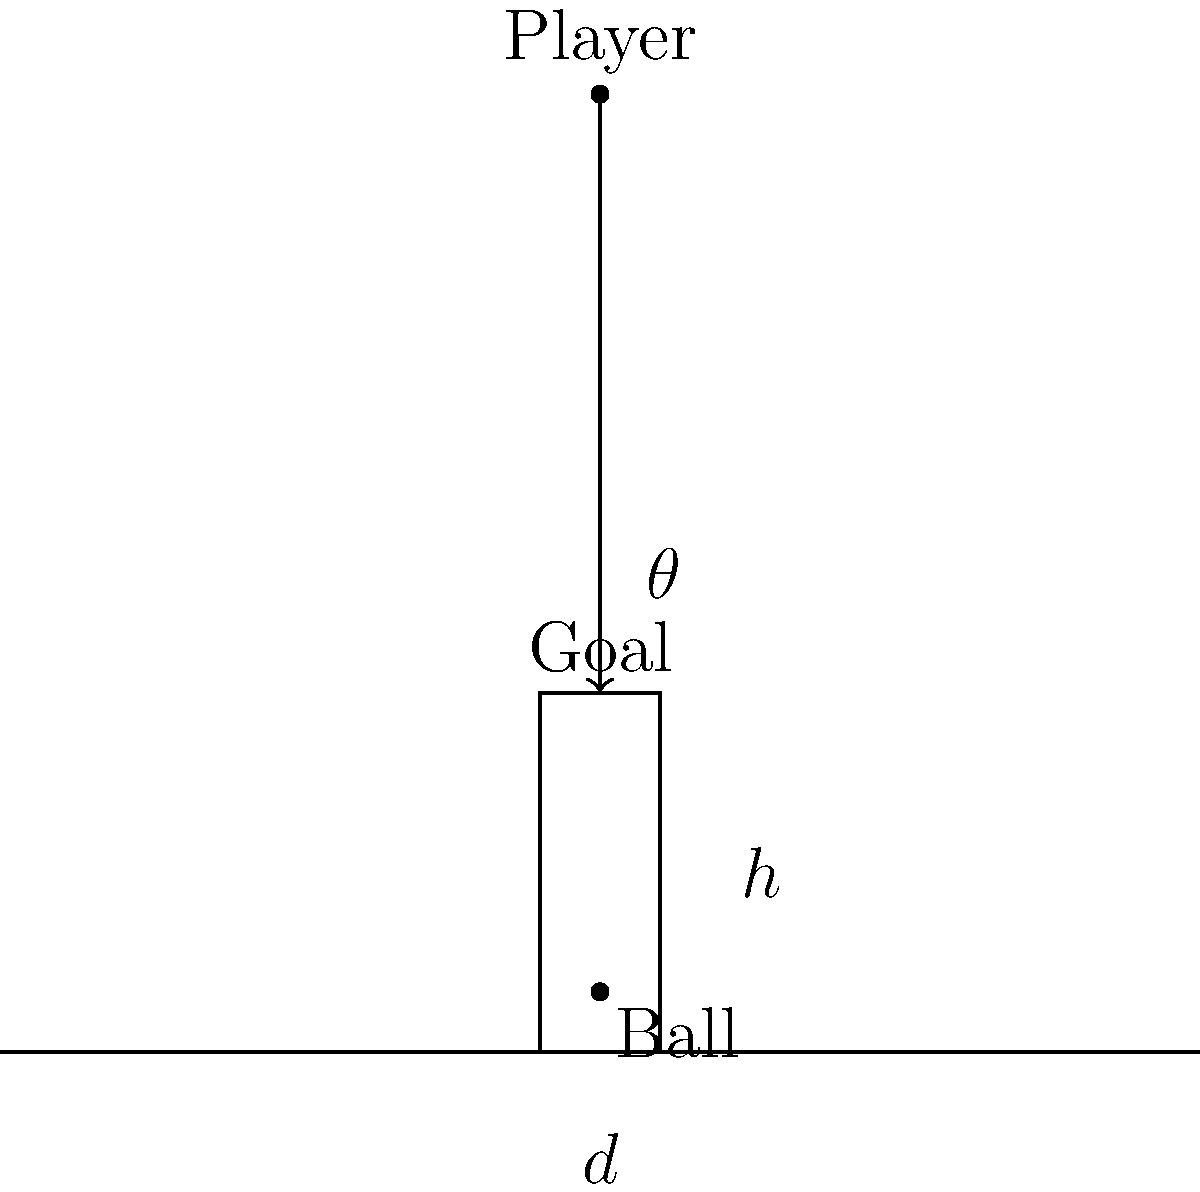As a rugby coach, you're teaching your young players about the optimal angle for kicking. Given a scenario where the ball is placed 5 meters in front of the goal posts, and the kicker is standing 80 meters away from the goal line, what is the optimal angle $\theta$ (in degrees) for the kick to clear the crossbar, which is 3 meters high? Assume the kick follows a straight line trajectory. To solve this problem, we'll use basic trigonometry:

1) First, let's identify the known values:
   - Distance from kicker to goal line (d) = 80 meters
   - Distance from ball to goal posts = 5 meters
   - Height of crossbar (h) = 3 meters

2) We need to find the angle $\theta$ that the kick makes with the ground.

3) We can use the tangent function to relate the angle to the height and distance:

   $\tan(\theta) = \frac{\text{opposite}}{\text{adjacent}} = \frac{h}{d}$

4) However, we need to adjust our distance. The total horizontal distance the ball travels is:
   80 (distance to goal line) - 5 (distance from goal line to posts) = 75 meters

5) Now we can set up our equation:

   $\tan(\theta) = \frac{3}{75} = \frac{1}{25}$

6) To find $\theta$, we need to use the inverse tangent (arctan) function:

   $\theta = \arctan(\frac{1}{25})$

7) Using a calculator or computer, we can compute this value:

   $\theta \approx 2.2906$ degrees

8) Rounding to two decimal places:

   $\theta \approx 2.29$ degrees

This angle will allow the ball to just clear the crossbar.
Answer: $2.29^\circ$ 